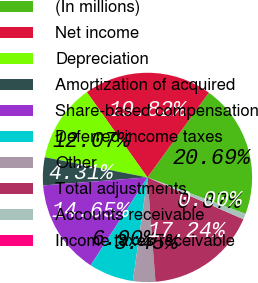<chart> <loc_0><loc_0><loc_500><loc_500><pie_chart><fcel>(In millions)<fcel>Net income<fcel>Depreciation<fcel>Amortization of acquired<fcel>Share-based compensation<fcel>Deferred income taxes<fcel>Other<fcel>Total adjustments<fcel>Accounts receivable<fcel>Income taxes receivable<nl><fcel>20.69%<fcel>19.82%<fcel>12.07%<fcel>4.31%<fcel>14.65%<fcel>6.9%<fcel>3.45%<fcel>17.24%<fcel>0.87%<fcel>0.0%<nl></chart> 